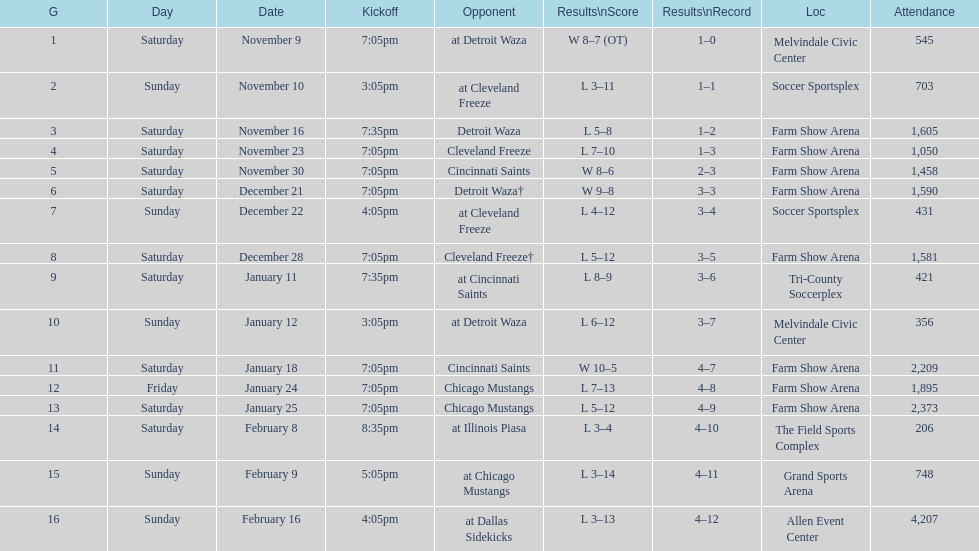How many times did the team play at home but did not win? 5. 